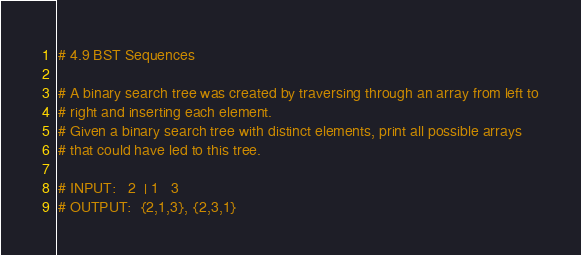<code> <loc_0><loc_0><loc_500><loc_500><_Python_># 4.9 BST Sequences

# A binary search tree was created by traversing through an array from left to
# right and inserting each element.
# Given a binary search tree with distinct elements, print all possible arrays
# that could have led to this tree.

# INPUT:   2  | 1   3
# OUTPUT:  {2,1,3}, {2,3,1}
</code> 